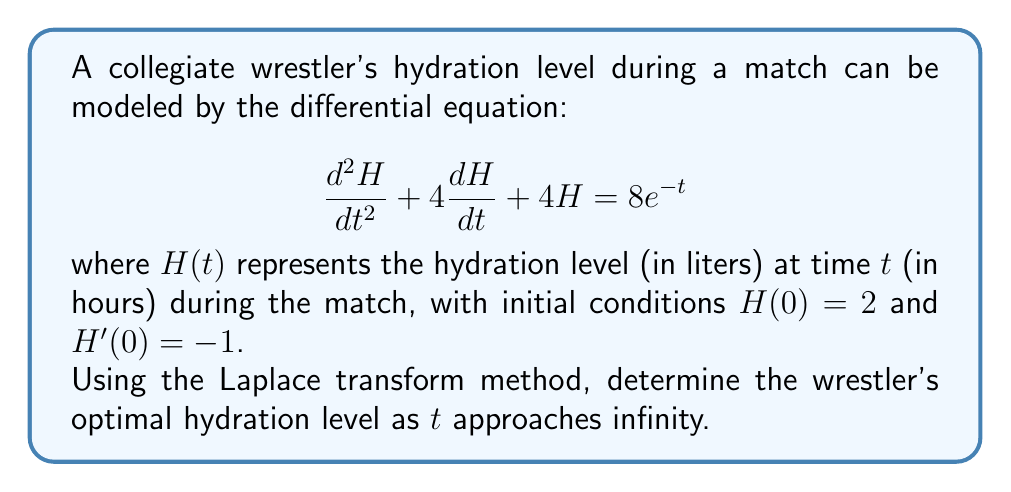Provide a solution to this math problem. 1) First, let's take the Laplace transform of both sides of the equation:
   $$\mathcal{L}\{H''(t) + 4H'(t) + 4H(t)\} = \mathcal{L}\{8e^{-t}\}$$

2) Using Laplace transform properties:
   $$(s^2H(s) - sH(0) - H'(0)) + 4(sH(s) - H(0)) + 4H(s) = \frac{8}{s+1}$$

3) Substitute the initial conditions $H(0) = 2$ and $H'(0) = -1$:
   $$(s^2H(s) - 2s + 1) + 4(sH(s) - 2) + 4H(s) = \frac{8}{s+1}$$

4) Simplify:
   $$s^2H(s) + 4sH(s) + 4H(s) - 2s - 7 = \frac{8}{s+1}$$
   $$(s^2 + 4s + 4)H(s) = \frac{8}{s+1} + 2s + 7$$

5) Solve for $H(s)$:
   $$H(s) = \frac{8}{(s+1)(s^2 + 4s + 4)} + \frac{2s + 7}{s^2 + 4s + 4}$$

6) To find the limit as $t$ approaches infinity, we use the Final Value Theorem:
   $$\lim_{t \to \infty} H(t) = \lim_{s \to 0} sH(s)$$

7) Calculate the limit:
   $$\lim_{s \to 0} s\left(\frac{8}{(s+1)(s^2 + 4s + 4)} + \frac{2s + 7}{s^2 + 4s + 4}\right)$$
   $$= \lim_{s \to 0} \frac{8s}{(s+1)(s^2 + 4s + 4)} + \frac{2s^2 + 7s}{s^2 + 4s + 4}$$
   $$= 0 + \frac{7}{4} = 1.75$$

Therefore, the optimal hydration level as $t$ approaches infinity is 1.75 liters.
Answer: 1.75 liters 